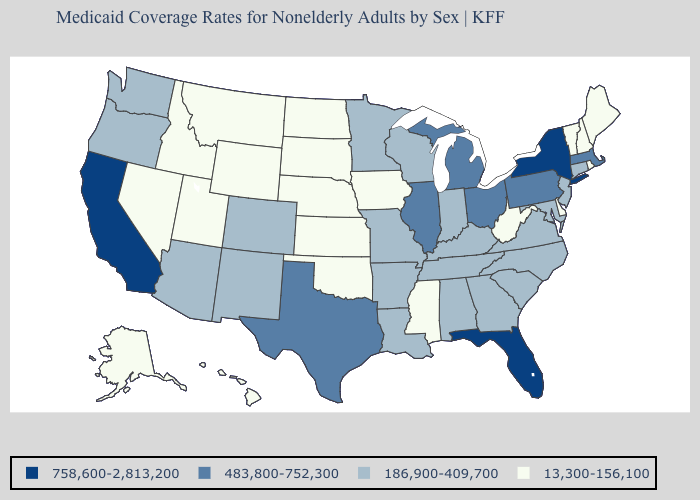Which states have the lowest value in the USA?
Quick response, please. Alaska, Delaware, Hawaii, Idaho, Iowa, Kansas, Maine, Mississippi, Montana, Nebraska, Nevada, New Hampshire, North Dakota, Oklahoma, Rhode Island, South Dakota, Utah, Vermont, West Virginia, Wyoming. What is the lowest value in the South?
Short answer required. 13,300-156,100. What is the value of New Hampshire?
Keep it brief. 13,300-156,100. Name the states that have a value in the range 758,600-2,813,200?
Write a very short answer. California, Florida, New York. What is the value of Michigan?
Keep it brief. 483,800-752,300. What is the value of Wisconsin?
Be succinct. 186,900-409,700. Which states have the lowest value in the USA?
Answer briefly. Alaska, Delaware, Hawaii, Idaho, Iowa, Kansas, Maine, Mississippi, Montana, Nebraska, Nevada, New Hampshire, North Dakota, Oklahoma, Rhode Island, South Dakota, Utah, Vermont, West Virginia, Wyoming. What is the value of Texas?
Keep it brief. 483,800-752,300. Name the states that have a value in the range 758,600-2,813,200?
Be succinct. California, Florida, New York. Which states have the lowest value in the USA?
Write a very short answer. Alaska, Delaware, Hawaii, Idaho, Iowa, Kansas, Maine, Mississippi, Montana, Nebraska, Nevada, New Hampshire, North Dakota, Oklahoma, Rhode Island, South Dakota, Utah, Vermont, West Virginia, Wyoming. Name the states that have a value in the range 13,300-156,100?
Concise answer only. Alaska, Delaware, Hawaii, Idaho, Iowa, Kansas, Maine, Mississippi, Montana, Nebraska, Nevada, New Hampshire, North Dakota, Oklahoma, Rhode Island, South Dakota, Utah, Vermont, West Virginia, Wyoming. Name the states that have a value in the range 13,300-156,100?
Be succinct. Alaska, Delaware, Hawaii, Idaho, Iowa, Kansas, Maine, Mississippi, Montana, Nebraska, Nevada, New Hampshire, North Dakota, Oklahoma, Rhode Island, South Dakota, Utah, Vermont, West Virginia, Wyoming. Does Illinois have the same value as Nebraska?
Give a very brief answer. No. What is the lowest value in the USA?
Keep it brief. 13,300-156,100. 